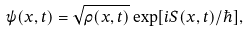<formula> <loc_0><loc_0><loc_500><loc_500>\psi ( x , t ) = \sqrt { \rho ( x , t ) } \exp [ i S ( x , t ) / \hbar { ] } ,</formula> 